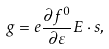Convert formula to latex. <formula><loc_0><loc_0><loc_500><loc_500>g = e \frac { \partial f ^ { 0 } } { \partial \varepsilon } E \cdot s ,</formula> 